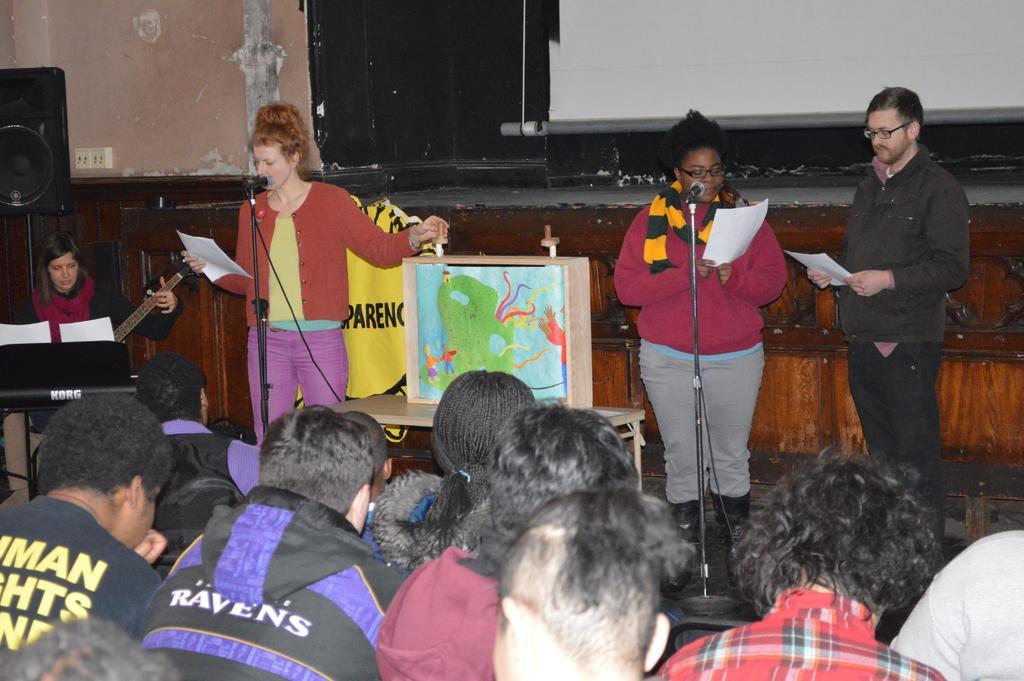Could you give a brief overview of what you see in this image? In this image there are group of persons sitting, there are persons truncated towards the bottom of the image, there are three persons standing, there are persons holding an object, there is a person playing a musical instrument, there are persons singing, there is an object truncated towards the left of the image,there is a table, there is an object on the table, there is a screen truncated towards the top of the image, at the background of the image there is a wall. 